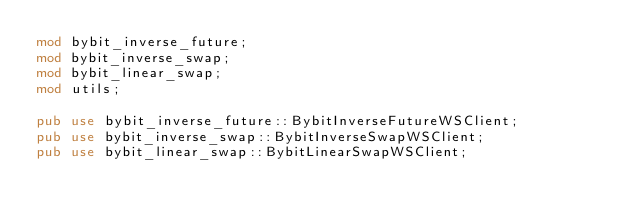Convert code to text. <code><loc_0><loc_0><loc_500><loc_500><_Rust_>mod bybit_inverse_future;
mod bybit_inverse_swap;
mod bybit_linear_swap;
mod utils;

pub use bybit_inverse_future::BybitInverseFutureWSClient;
pub use bybit_inverse_swap::BybitInverseSwapWSClient;
pub use bybit_linear_swap::BybitLinearSwapWSClient;
</code> 